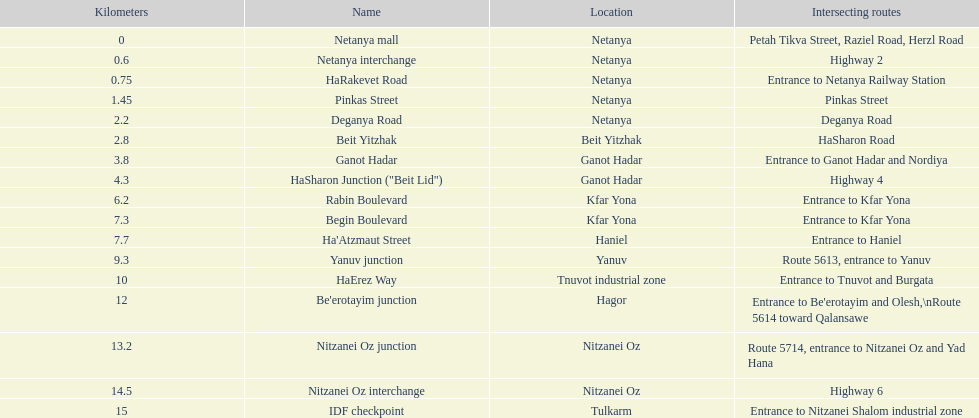Which section is longest?? IDF checkpoint. 